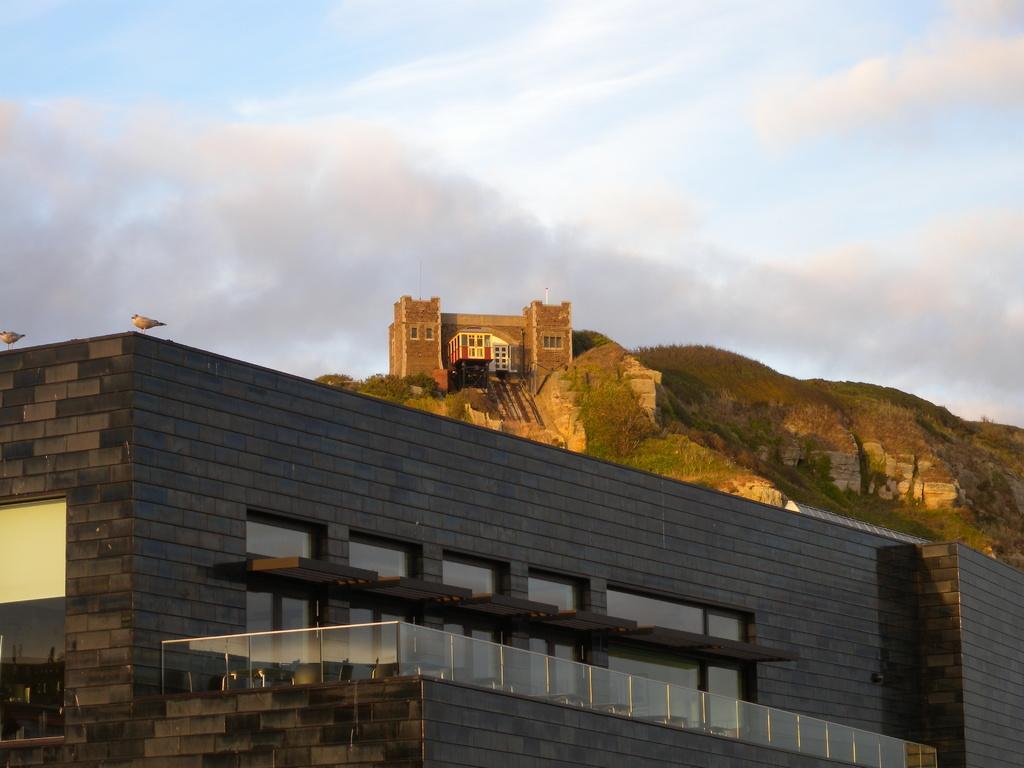Could you give a brief overview of what you see in this image? In this image there is a building with plants , chairs and birds , there is another building on the top of the hill, and in the background there is sky. 